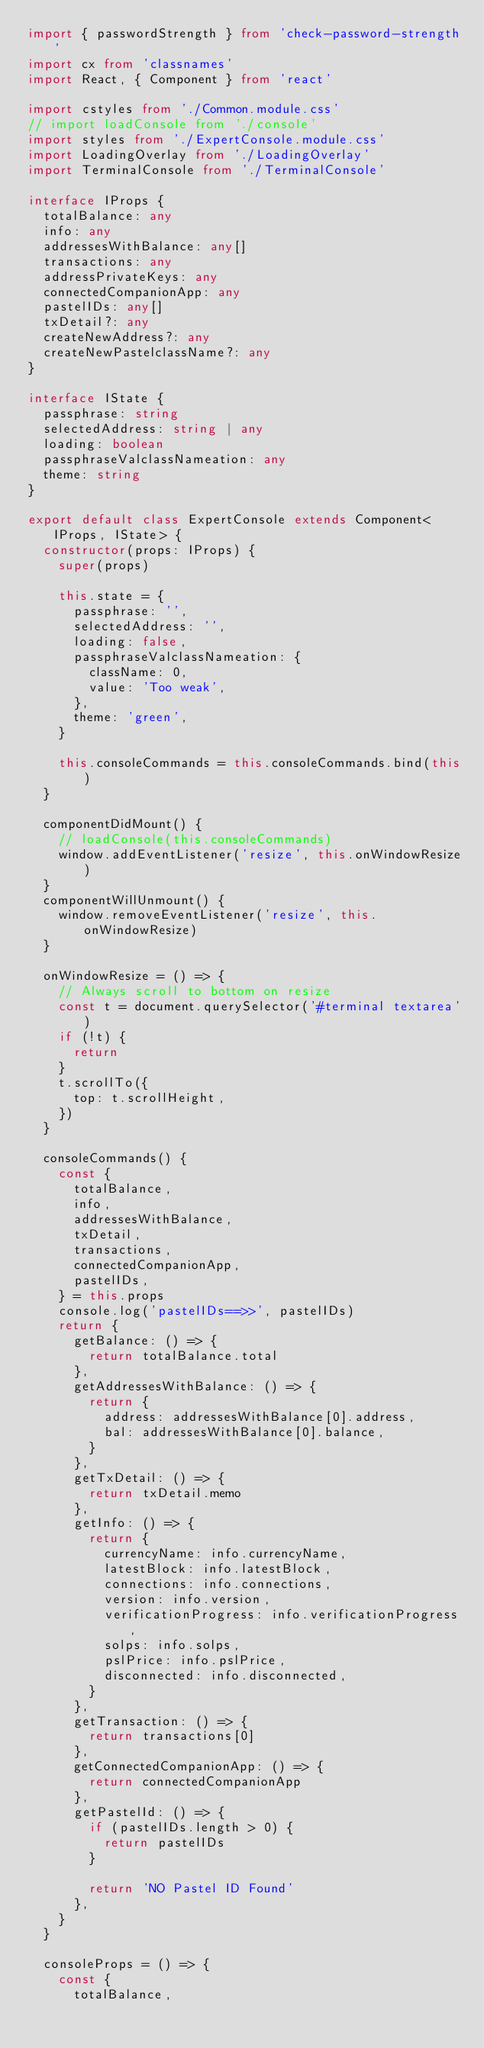<code> <loc_0><loc_0><loc_500><loc_500><_TypeScript_>import { passwordStrength } from 'check-password-strength'
import cx from 'classnames'
import React, { Component } from 'react'

import cstyles from './Common.module.css'
// import loadConsole from './console'
import styles from './ExpertConsole.module.css'
import LoadingOverlay from './LoadingOverlay'
import TerminalConsole from './TerminalConsole'

interface IProps {
  totalBalance: any
  info: any
  addressesWithBalance: any[]
  transactions: any
  addressPrivateKeys: any
  connectedCompanionApp: any
  pastelIDs: any[]
  txDetail?: any
  createNewAddress?: any
  createNewPastelclassName?: any
}

interface IState {
  passphrase: string
  selectedAddress: string | any
  loading: boolean
  passphraseValclassNameation: any
  theme: string
}

export default class ExpertConsole extends Component<IProps, IState> {
  constructor(props: IProps) {
    super(props)

    this.state = {
      passphrase: '',
      selectedAddress: '',
      loading: false,
      passphraseValclassNameation: {
        className: 0,
        value: 'Too weak',
      },
      theme: 'green',
    }

    this.consoleCommands = this.consoleCommands.bind(this)
  }

  componentDidMount() {
    // loadConsole(this.consoleCommands)
    window.addEventListener('resize', this.onWindowResize)
  }
  componentWillUnmount() {
    window.removeEventListener('resize', this.onWindowResize)
  }

  onWindowResize = () => {
    // Always scroll to bottom on resize
    const t = document.querySelector('#terminal textarea')
    if (!t) {
      return
    }
    t.scrollTo({
      top: t.scrollHeight,
    })
  }

  consoleCommands() {
    const {
      totalBalance,
      info,
      addressesWithBalance,
      txDetail,
      transactions,
      connectedCompanionApp,
      pastelIDs,
    } = this.props
    console.log('pastelIDs==>>', pastelIDs)
    return {
      getBalance: () => {
        return totalBalance.total
      },
      getAddressesWithBalance: () => {
        return {
          address: addressesWithBalance[0].address,
          bal: addressesWithBalance[0].balance,
        }
      },
      getTxDetail: () => {
        return txDetail.memo
      },
      getInfo: () => {
        return {
          currencyName: info.currencyName,
          latestBlock: info.latestBlock,
          connections: info.connections,
          version: info.version,
          verificationProgress: info.verificationProgress,
          solps: info.solps,
          pslPrice: info.pslPrice,
          disconnected: info.disconnected,
        }
      },
      getTransaction: () => {
        return transactions[0]
      },
      getConnectedCompanionApp: () => {
        return connectedCompanionApp
      },
      getPastelId: () => {
        if (pastelIDs.length > 0) {
          return pastelIDs
        }

        return 'NO Pastel ID Found'
      },
    }
  }

  consoleProps = () => {
    const {
      totalBalance,</code> 